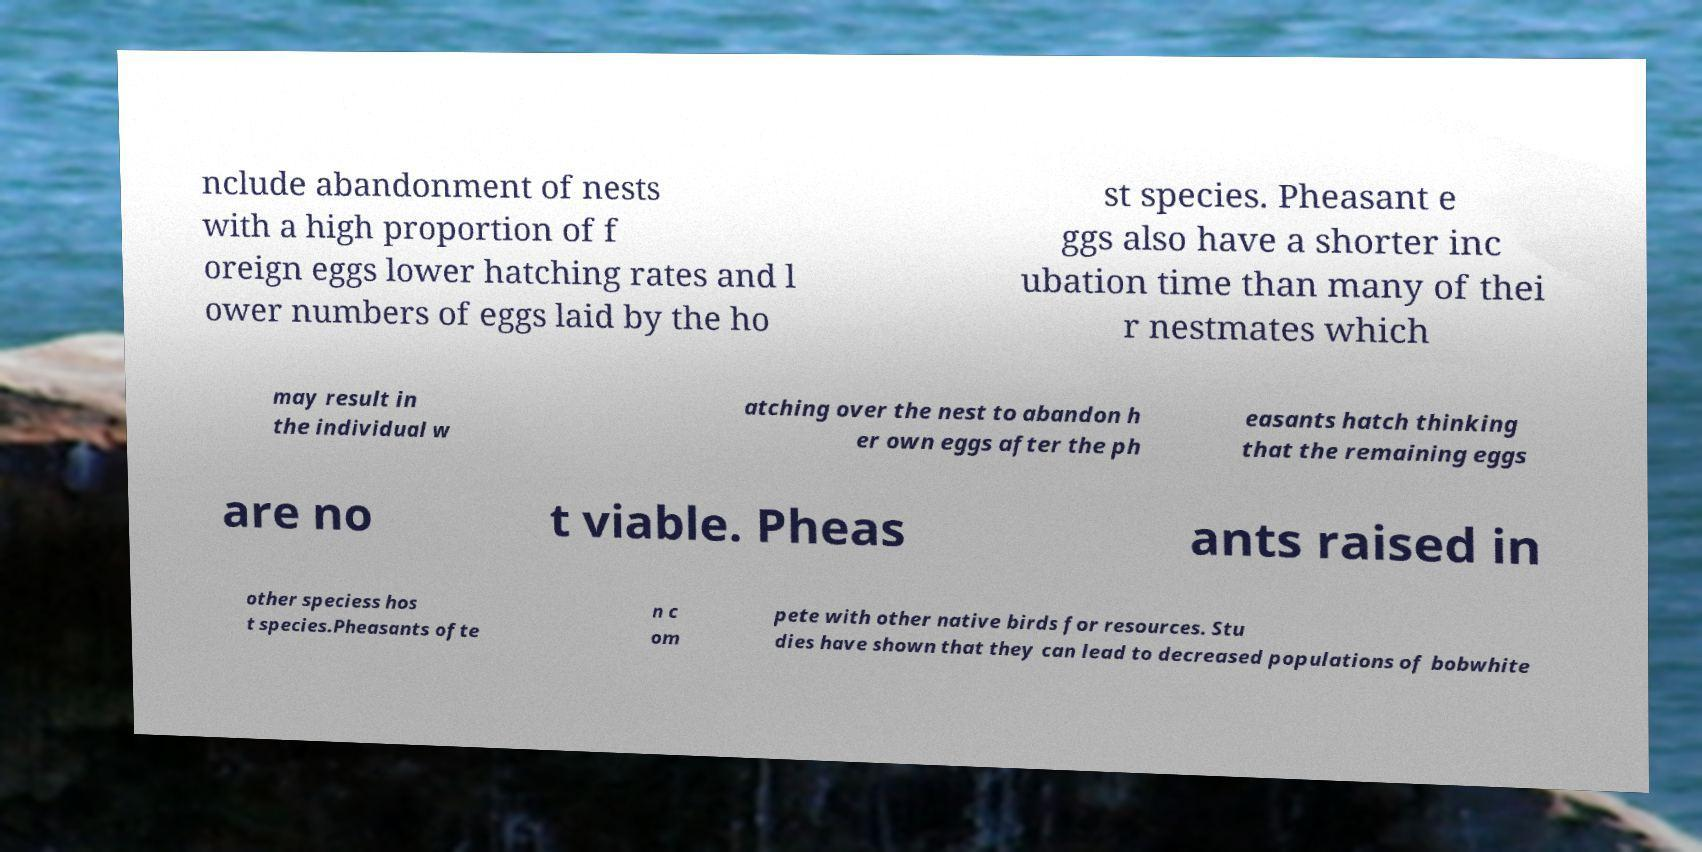Can you accurately transcribe the text from the provided image for me? nclude abandonment of nests with a high proportion of f oreign eggs lower hatching rates and l ower numbers of eggs laid by the ho st species. Pheasant e ggs also have a shorter inc ubation time than many of thei r nestmates which may result in the individual w atching over the nest to abandon h er own eggs after the ph easants hatch thinking that the remaining eggs are no t viable. Pheas ants raised in other speciess hos t species.Pheasants ofte n c om pete with other native birds for resources. Stu dies have shown that they can lead to decreased populations of bobwhite 